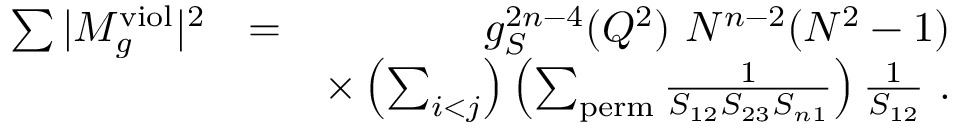Convert formula to latex. <formula><loc_0><loc_0><loc_500><loc_500>\begin{array} { r l r } { \sum | M _ { g } ^ { v i o l } | ^ { 2 } } & { = } & { g _ { S } ^ { 2 n - 4 } ( Q ^ { 2 } ) N ^ { n - 2 } ( N ^ { 2 } - 1 ) } \\ & { \times \left ( \sum _ { i < j } \right ) \left ( \sum _ { p e r m } \frac { 1 } { S _ { 1 2 } S _ { 2 3 } S _ { n 1 } } \right ) \frac { 1 } { S _ { 1 2 } } . } \end{array}</formula> 